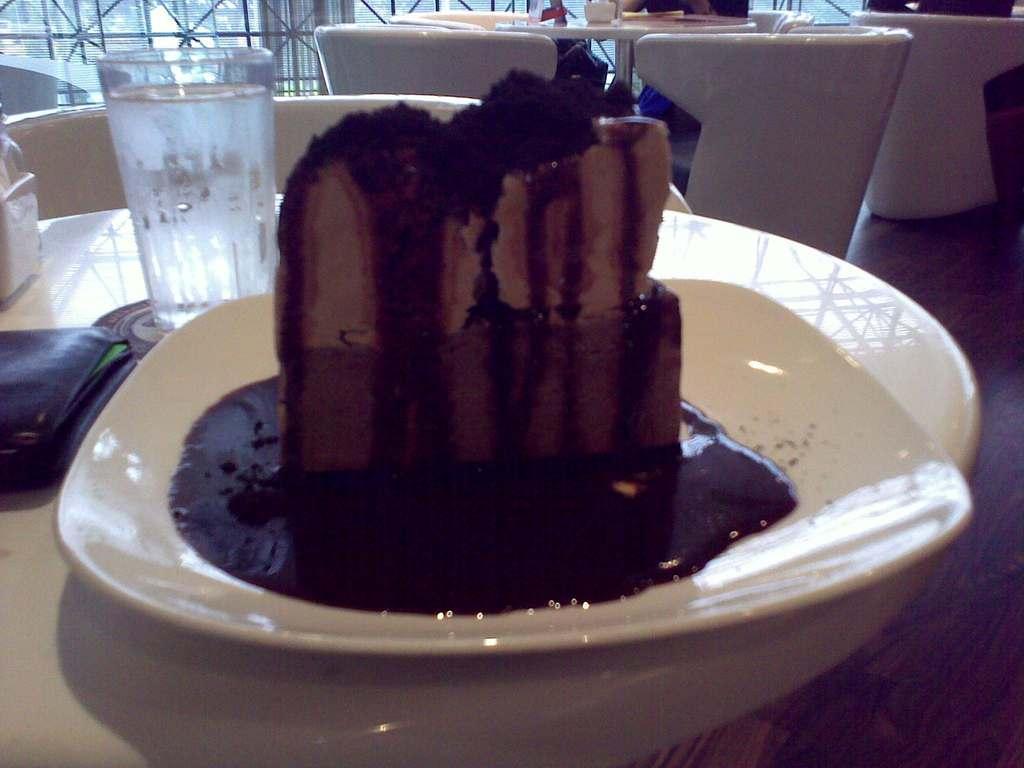In one or two sentences, can you explain what this image depicts? In the foreground of the picture I can see a piece of cake on the plate. I can see the tables and chairs on the floor. I can see a glass of water and a wallet are kept on the table. Looks like there is a person on the top right side of the picture. In the background, I can see the metal grill fence and glass windows. 